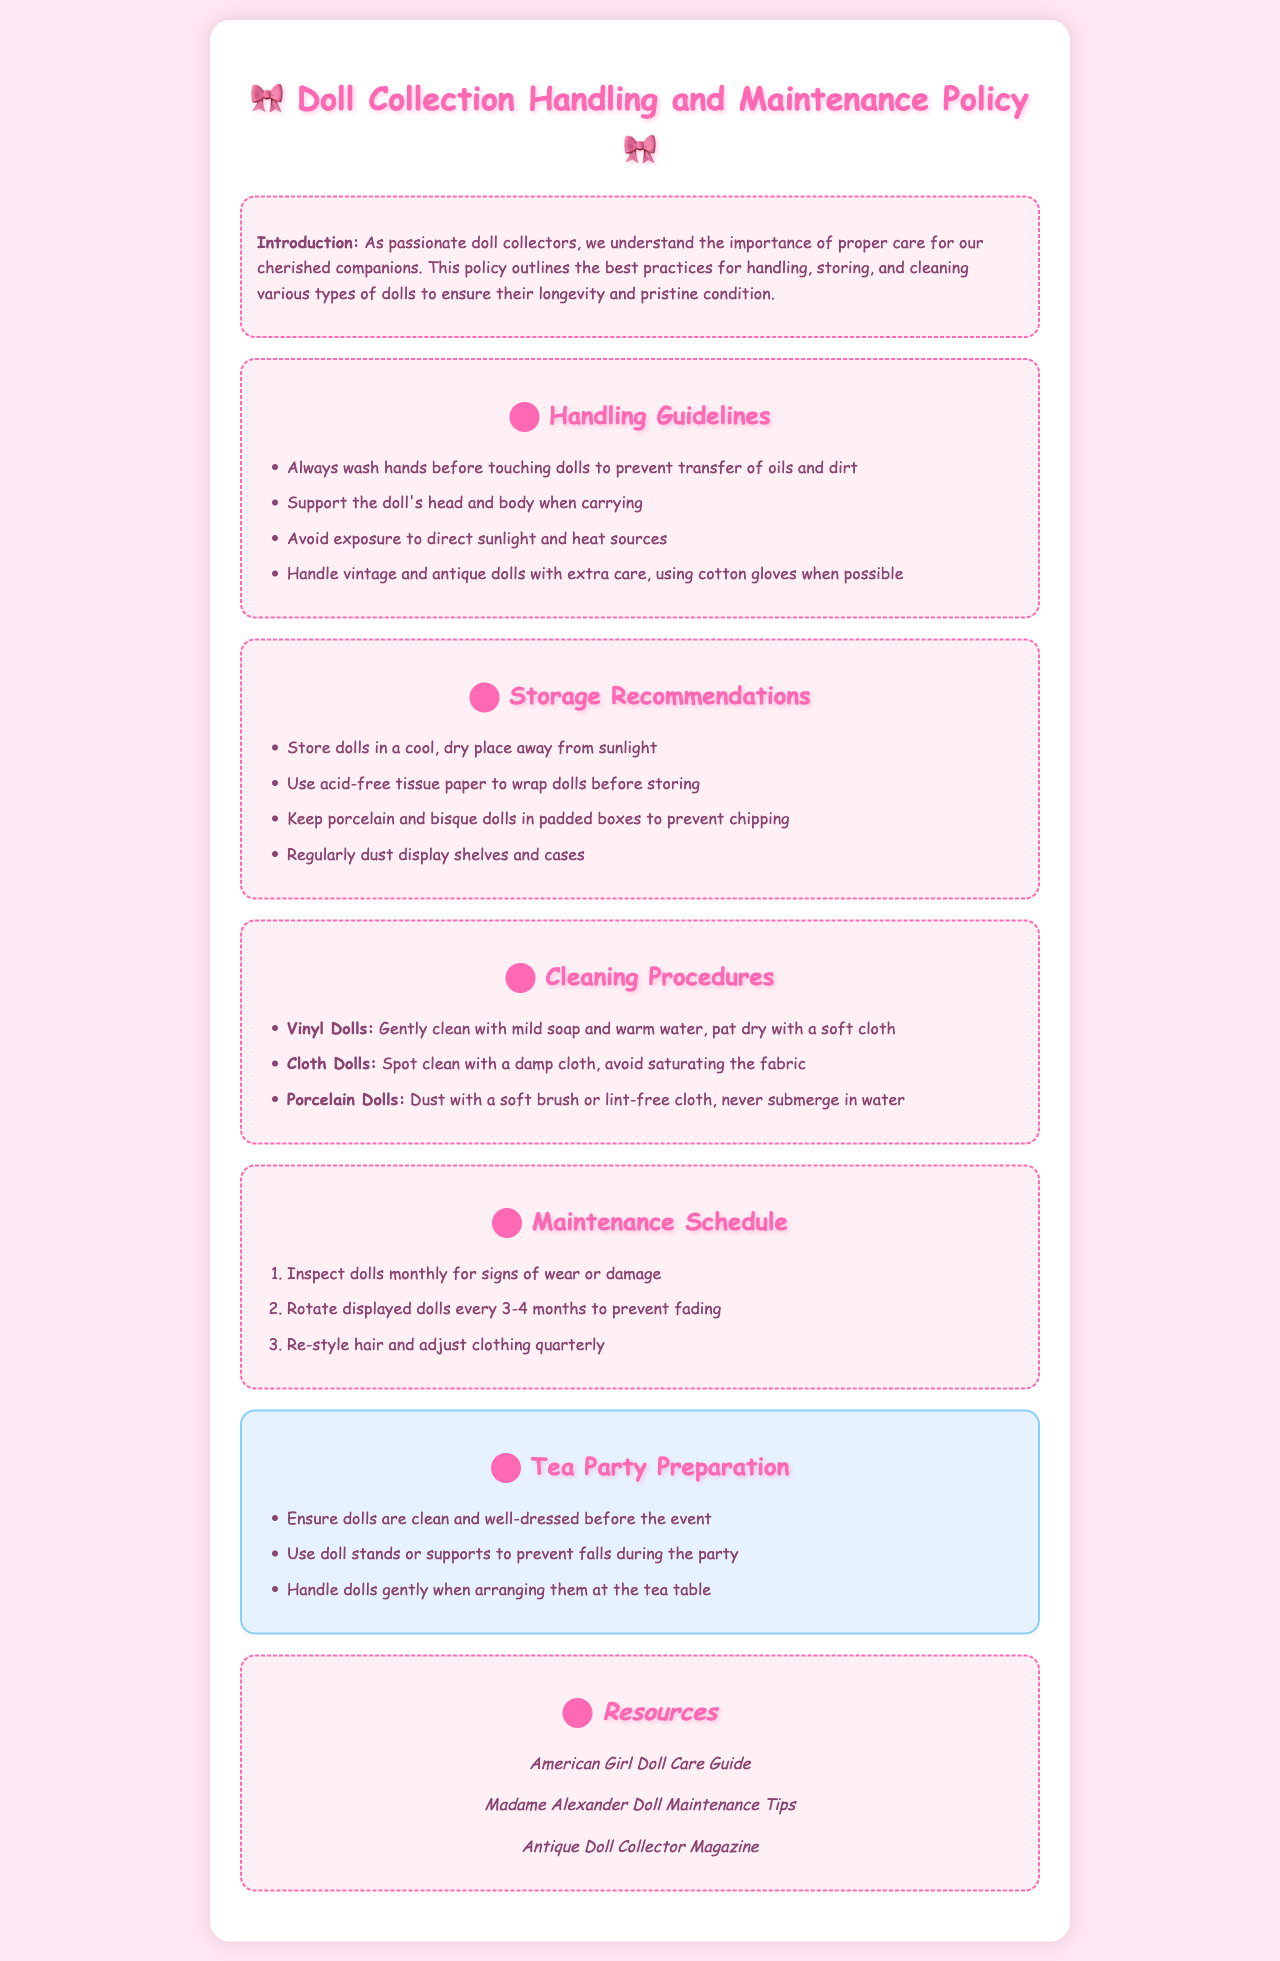What is the title of the document? The title of the document is stated in the header section of the rendered page.
Answer: Doll Collection Handling and Maintenance Policy What should you use to wrap dolls before storing? This information is found under the storage recommendations section.
Answer: Acid-free tissue paper How often should dolls be inspected for signs of wear? The maintenance schedule section mentions the frequency of inspections.
Answer: Monthly Which type of dolls should you never submerge in water? This is mentioned in the cleaning procedures specific to porcelain dolls.
Answer: Porcelain Dolls What is suggested to handle vintage and antique dolls? The handling guidelines section specifically describes this care practice.
Answer: Cotton gloves How long should you rotate displayed dolls to prevent fading? This information is found in the maintenance schedule section.
Answer: Every 3-4 months What color is the background of the document? The background color is mentioned in the style section of the HTML.
Answer: #ffe6f2 What is one resource listed for doll maintenance? This refers to the resources section of the document.
Answer: American Girl Doll Care Guide 